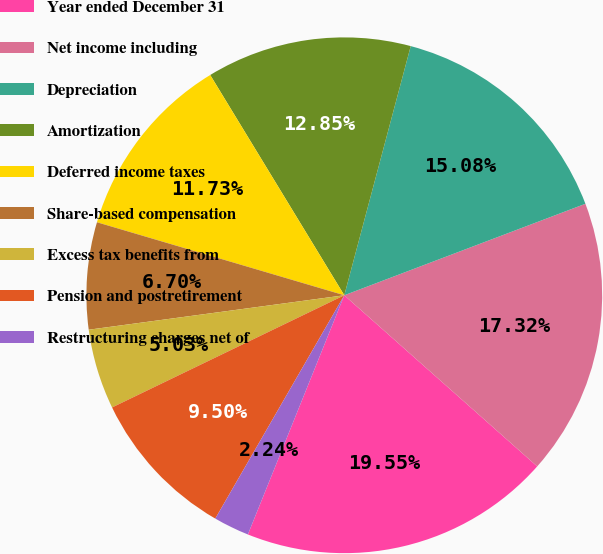Convert chart to OTSL. <chart><loc_0><loc_0><loc_500><loc_500><pie_chart><fcel>Year ended December 31<fcel>Net income including<fcel>Depreciation<fcel>Amortization<fcel>Deferred income taxes<fcel>Share-based compensation<fcel>Excess tax benefits from<fcel>Pension and postretirement<fcel>Restructuring charges net of<nl><fcel>19.55%<fcel>17.32%<fcel>15.08%<fcel>12.85%<fcel>11.73%<fcel>6.7%<fcel>5.03%<fcel>9.5%<fcel>2.24%<nl></chart> 